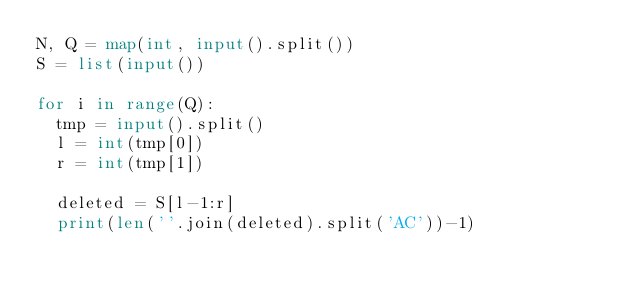Convert code to text. <code><loc_0><loc_0><loc_500><loc_500><_Python_>N, Q = map(int, input().split())
S = list(input())

for i in range(Q):
  tmp = input().split()
  l = int(tmp[0])
  r = int(tmp[1])
  
  deleted = S[l-1:r]
  print(len(''.join(deleted).split('AC'))-1)</code> 